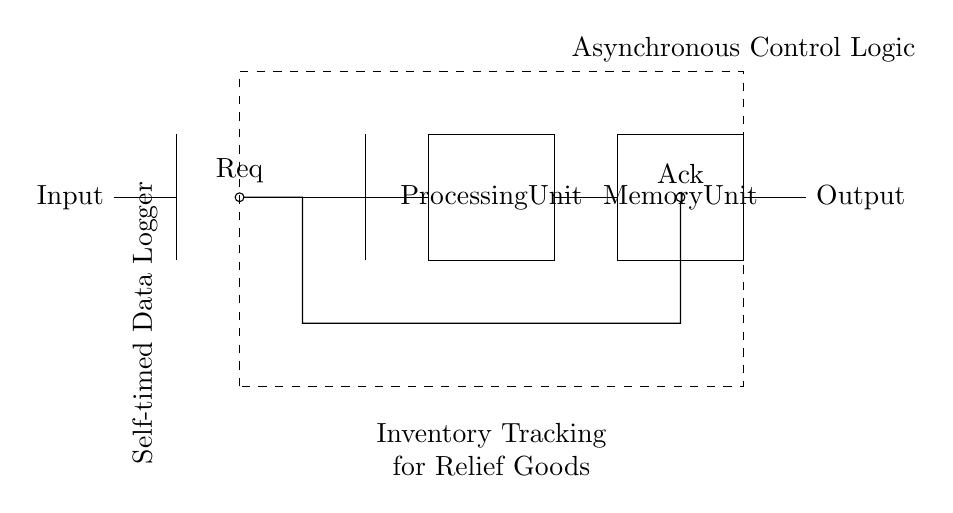What type of control logic is used in this circuit? The circuit employs Asynchronous Control Logic, which manages the operations without requiring a global clock signal. It allows different parts of the circuit to operate independently and respond to conditions as they occur.
Answer: Asynchronous Control Logic What is the function of the Processing Unit in this circuit? The Processing Unit is responsible for processing the data received from the Input stage and determining the necessary actions based on that data. It coordinates the flow of information between the input, memory, and output stages.
Answer: Processing data How many main components are present in this circuit diagram? The main components in this circuit diagram include the Input, Processing Unit, Memory Unit, and Output, totaling four notable components.
Answer: Four What do the symbols Req and Ack represent in this diagram? Req stands for "Request" and Ack stands for "Acknowledge." These signals facilitate communication between different components in the circuit, indicating whether a request for data has been made and acknowledged.
Answer: Request and Acknowledge Which unit is responsible for storing data in this circuit? The Memory Unit is responsible for storing data. It temporarily holds the processed information until it is required for output or further processing.
Answer: Memory Unit What is the significance of the Request-Acknowledge handshake in this circuit? The Request-Acknowledge handshake ensures reliable communication between the components. It signifies that the Sending Unit has requested data and that the Receiving Unit has acknowledged that request, which prevents data loss and ensures proper timing.
Answer: Reliable communication What is the purpose of the dashed rectangle in the circuit diagram? The dashed rectangle encloses the Asynchronous Control Logic and indicates that this section is responsible for managing the timing and coordination of the entire data logging process without a centralized clock signal, demonstrating its asynchronous nature.
Answer: Control management 